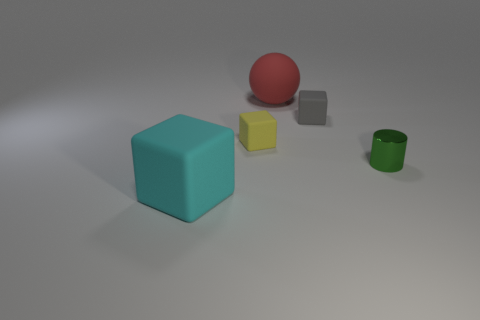What is the color of the metallic object?
Provide a short and direct response. Green. What number of other things are there of the same shape as the cyan matte thing?
Ensure brevity in your answer.  2. Is the number of red balls that are right of the large red thing the same as the number of things in front of the green metallic thing?
Your response must be concise. No. What material is the red object?
Provide a succinct answer. Rubber. What is the material of the cylinder that is right of the large red matte ball?
Your answer should be compact. Metal. Is there any other thing that is the same material as the cyan object?
Give a very brief answer. Yes. Is the number of red things right of the yellow block greater than the number of big blue cylinders?
Offer a terse response. Yes. Are there any big objects that are behind the big object that is in front of the large object that is behind the big block?
Give a very brief answer. Yes. There is a gray matte cube; are there any small cubes in front of it?
Your response must be concise. Yes. What size is the sphere that is the same material as the big cyan block?
Your answer should be very brief. Large. 